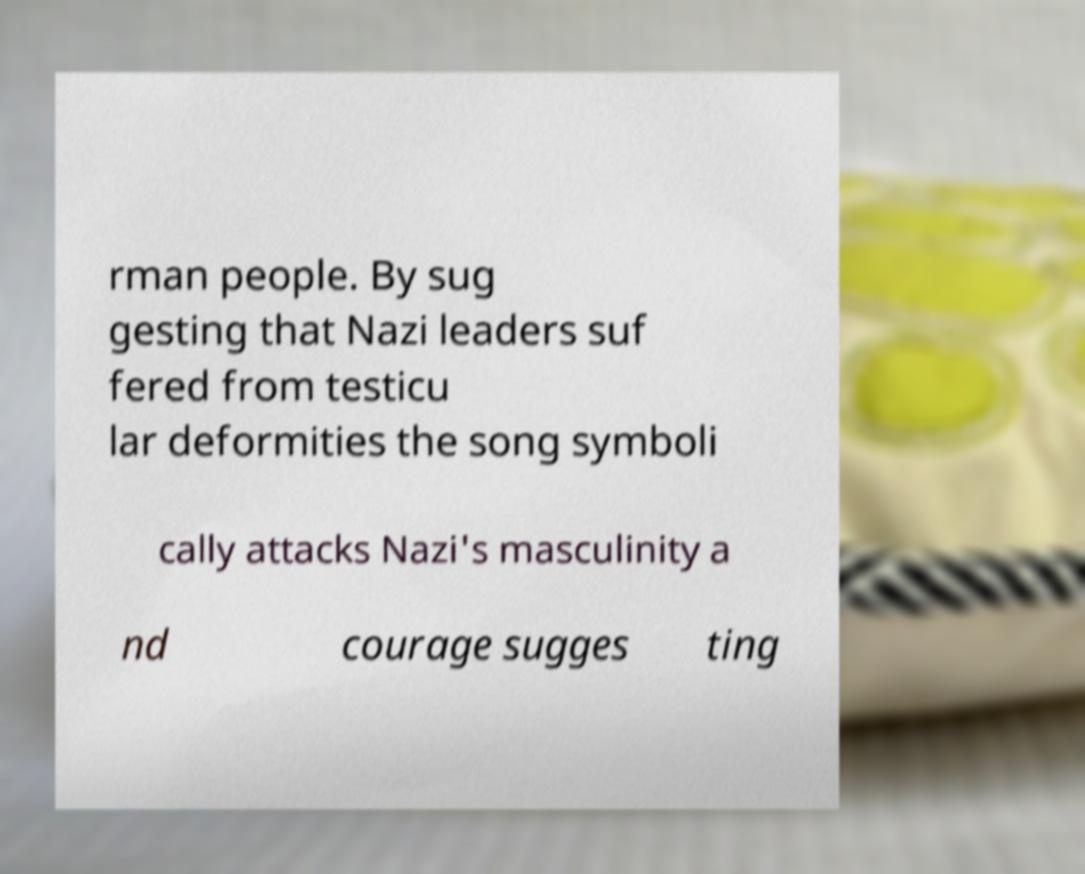Please identify and transcribe the text found in this image. rman people. By sug gesting that Nazi leaders suf fered from testicu lar deformities the song symboli cally attacks Nazi's masculinity a nd courage sugges ting 